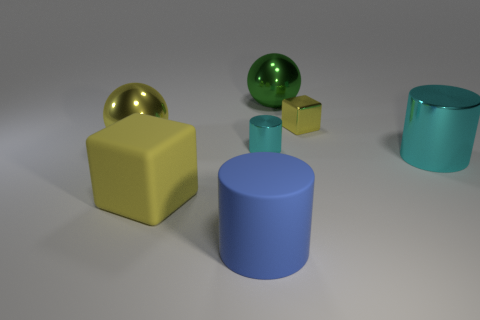How many things are the same color as the big matte cube?
Your response must be concise. 2. The metallic sphere behind the large metallic sphere that is on the left side of the large blue cylinder that is left of the large cyan metallic object is what color?
Your answer should be compact. Green. There is a blue rubber cylinder; is its size the same as the yellow shiny object on the right side of the big yellow rubber block?
Offer a terse response. No. How many objects are either big things in front of the matte cube or big metal objects that are left of the small block?
Make the answer very short. 3. There is a cyan metal thing that is the same size as the yellow sphere; what is its shape?
Ensure brevity in your answer.  Cylinder. There is a big metal object that is behind the big shiny ball that is in front of the yellow block that is right of the blue object; what shape is it?
Ensure brevity in your answer.  Sphere. Are there the same number of green metal objects that are in front of the big green shiny object and large matte balls?
Provide a short and direct response. Yes. Do the matte cylinder and the yellow shiny block have the same size?
Give a very brief answer. No. What number of matte objects are small yellow cubes or tiny green things?
Keep it short and to the point. 0. There is a blue thing that is the same size as the matte block; what material is it?
Offer a very short reply. Rubber. 